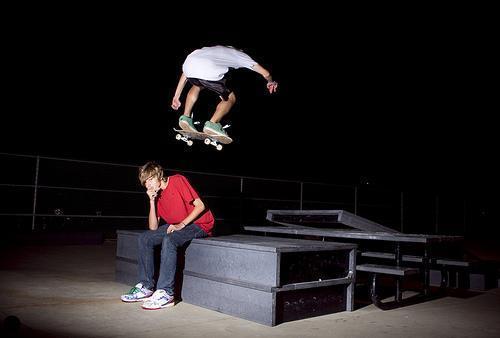How many benches are in the photo?
Give a very brief answer. 1. How many people can be seen?
Give a very brief answer. 2. 